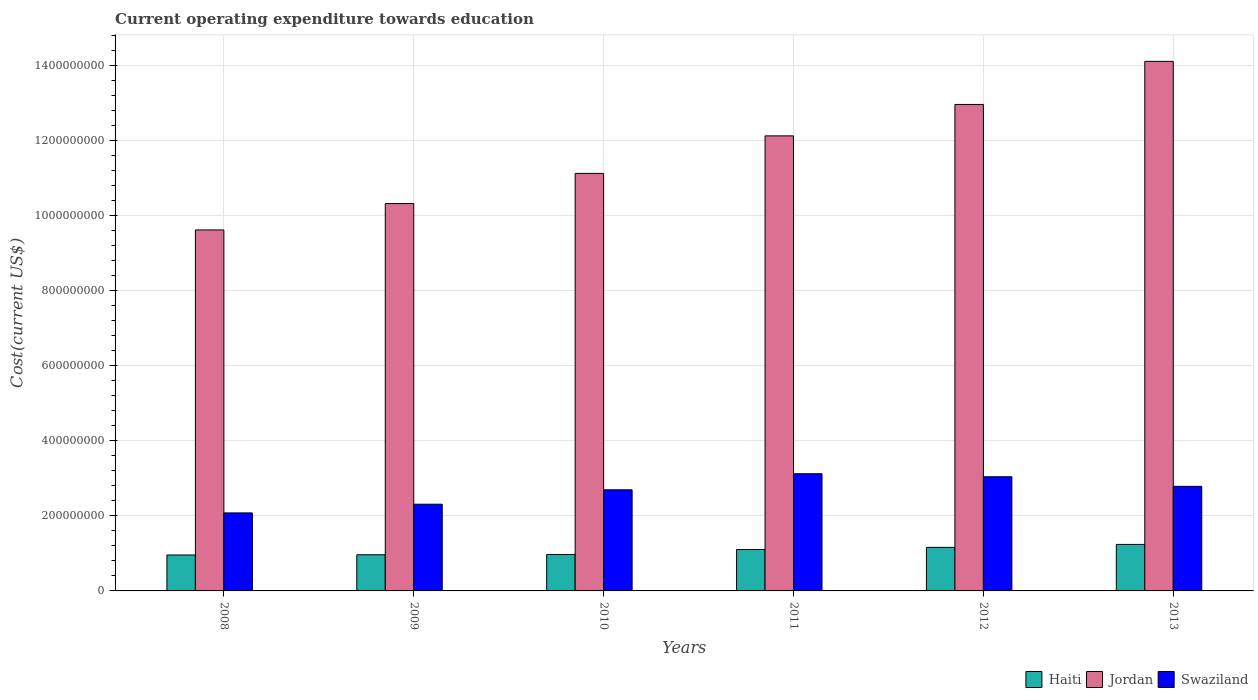How many groups of bars are there?
Keep it short and to the point. 6. Are the number of bars per tick equal to the number of legend labels?
Provide a succinct answer. Yes. Are the number of bars on each tick of the X-axis equal?
Make the answer very short. Yes. How many bars are there on the 4th tick from the right?
Provide a succinct answer. 3. What is the label of the 3rd group of bars from the left?
Your response must be concise. 2010. What is the expenditure towards education in Haiti in 2013?
Your response must be concise. 1.24e+08. Across all years, what is the maximum expenditure towards education in Haiti?
Your response must be concise. 1.24e+08. Across all years, what is the minimum expenditure towards education in Jordan?
Your answer should be very brief. 9.63e+08. In which year was the expenditure towards education in Jordan minimum?
Your answer should be very brief. 2008. What is the total expenditure towards education in Jordan in the graph?
Keep it short and to the point. 7.03e+09. What is the difference between the expenditure towards education in Swaziland in 2009 and that in 2010?
Your answer should be very brief. -3.84e+07. What is the difference between the expenditure towards education in Jordan in 2011 and the expenditure towards education in Swaziland in 2009?
Make the answer very short. 9.82e+08. What is the average expenditure towards education in Swaziland per year?
Make the answer very short. 2.67e+08. In the year 2010, what is the difference between the expenditure towards education in Haiti and expenditure towards education in Swaziland?
Make the answer very short. -1.73e+08. In how many years, is the expenditure towards education in Swaziland greater than 1280000000 US$?
Provide a short and direct response. 0. What is the ratio of the expenditure towards education in Swaziland in 2010 to that in 2011?
Your response must be concise. 0.86. Is the expenditure towards education in Swaziland in 2008 less than that in 2010?
Provide a succinct answer. Yes. What is the difference between the highest and the second highest expenditure towards education in Jordan?
Give a very brief answer. 1.15e+08. What is the difference between the highest and the lowest expenditure towards education in Jordan?
Your answer should be very brief. 4.50e+08. In how many years, is the expenditure towards education in Swaziland greater than the average expenditure towards education in Swaziland taken over all years?
Ensure brevity in your answer.  4. What does the 1st bar from the left in 2012 represents?
Keep it short and to the point. Haiti. What does the 3rd bar from the right in 2009 represents?
Offer a terse response. Haiti. Is it the case that in every year, the sum of the expenditure towards education in Haiti and expenditure towards education in Swaziland is greater than the expenditure towards education in Jordan?
Keep it short and to the point. No. How many bars are there?
Keep it short and to the point. 18. How many years are there in the graph?
Your answer should be compact. 6. What is the difference between two consecutive major ticks on the Y-axis?
Ensure brevity in your answer.  2.00e+08. Are the values on the major ticks of Y-axis written in scientific E-notation?
Your response must be concise. No. Does the graph contain any zero values?
Provide a short and direct response. No. Does the graph contain grids?
Make the answer very short. Yes. Where does the legend appear in the graph?
Provide a succinct answer. Bottom right. How many legend labels are there?
Your answer should be very brief. 3. How are the legend labels stacked?
Give a very brief answer. Horizontal. What is the title of the graph?
Keep it short and to the point. Current operating expenditure towards education. What is the label or title of the Y-axis?
Provide a succinct answer. Cost(current US$). What is the Cost(current US$) in Haiti in 2008?
Your answer should be compact. 9.58e+07. What is the Cost(current US$) in Jordan in 2008?
Your response must be concise. 9.63e+08. What is the Cost(current US$) in Swaziland in 2008?
Provide a succinct answer. 2.08e+08. What is the Cost(current US$) in Haiti in 2009?
Your answer should be very brief. 9.64e+07. What is the Cost(current US$) of Jordan in 2009?
Make the answer very short. 1.03e+09. What is the Cost(current US$) of Swaziland in 2009?
Make the answer very short. 2.31e+08. What is the Cost(current US$) of Haiti in 2010?
Your answer should be very brief. 9.71e+07. What is the Cost(current US$) of Jordan in 2010?
Give a very brief answer. 1.11e+09. What is the Cost(current US$) of Swaziland in 2010?
Your answer should be compact. 2.70e+08. What is the Cost(current US$) in Haiti in 2011?
Your answer should be compact. 1.10e+08. What is the Cost(current US$) of Jordan in 2011?
Your response must be concise. 1.21e+09. What is the Cost(current US$) of Swaziland in 2011?
Give a very brief answer. 3.12e+08. What is the Cost(current US$) of Haiti in 2012?
Your answer should be compact. 1.16e+08. What is the Cost(current US$) of Jordan in 2012?
Make the answer very short. 1.30e+09. What is the Cost(current US$) in Swaziland in 2012?
Ensure brevity in your answer.  3.04e+08. What is the Cost(current US$) of Haiti in 2013?
Give a very brief answer. 1.24e+08. What is the Cost(current US$) in Jordan in 2013?
Make the answer very short. 1.41e+09. What is the Cost(current US$) of Swaziland in 2013?
Your answer should be compact. 2.79e+08. Across all years, what is the maximum Cost(current US$) in Haiti?
Provide a short and direct response. 1.24e+08. Across all years, what is the maximum Cost(current US$) of Jordan?
Provide a succinct answer. 1.41e+09. Across all years, what is the maximum Cost(current US$) in Swaziland?
Keep it short and to the point. 3.12e+08. Across all years, what is the minimum Cost(current US$) in Haiti?
Offer a terse response. 9.58e+07. Across all years, what is the minimum Cost(current US$) of Jordan?
Offer a terse response. 9.63e+08. Across all years, what is the minimum Cost(current US$) in Swaziland?
Provide a short and direct response. 2.08e+08. What is the total Cost(current US$) in Haiti in the graph?
Your answer should be very brief. 6.40e+08. What is the total Cost(current US$) in Jordan in the graph?
Offer a terse response. 7.03e+09. What is the total Cost(current US$) in Swaziland in the graph?
Offer a very short reply. 1.60e+09. What is the difference between the Cost(current US$) of Haiti in 2008 and that in 2009?
Provide a short and direct response. -6.34e+05. What is the difference between the Cost(current US$) in Jordan in 2008 and that in 2009?
Keep it short and to the point. -7.04e+07. What is the difference between the Cost(current US$) in Swaziland in 2008 and that in 2009?
Keep it short and to the point. -2.32e+07. What is the difference between the Cost(current US$) of Haiti in 2008 and that in 2010?
Give a very brief answer. -1.33e+06. What is the difference between the Cost(current US$) of Jordan in 2008 and that in 2010?
Make the answer very short. -1.51e+08. What is the difference between the Cost(current US$) of Swaziland in 2008 and that in 2010?
Your answer should be very brief. -6.16e+07. What is the difference between the Cost(current US$) in Haiti in 2008 and that in 2011?
Give a very brief answer. -1.46e+07. What is the difference between the Cost(current US$) in Jordan in 2008 and that in 2011?
Your response must be concise. -2.51e+08. What is the difference between the Cost(current US$) in Swaziland in 2008 and that in 2011?
Your response must be concise. -1.04e+08. What is the difference between the Cost(current US$) in Haiti in 2008 and that in 2012?
Keep it short and to the point. -2.03e+07. What is the difference between the Cost(current US$) in Jordan in 2008 and that in 2012?
Give a very brief answer. -3.35e+08. What is the difference between the Cost(current US$) of Swaziland in 2008 and that in 2012?
Make the answer very short. -9.64e+07. What is the difference between the Cost(current US$) of Haiti in 2008 and that in 2013?
Provide a short and direct response. -2.82e+07. What is the difference between the Cost(current US$) in Jordan in 2008 and that in 2013?
Give a very brief answer. -4.50e+08. What is the difference between the Cost(current US$) of Swaziland in 2008 and that in 2013?
Provide a short and direct response. -7.09e+07. What is the difference between the Cost(current US$) of Haiti in 2009 and that in 2010?
Make the answer very short. -6.92e+05. What is the difference between the Cost(current US$) of Jordan in 2009 and that in 2010?
Provide a succinct answer. -8.04e+07. What is the difference between the Cost(current US$) in Swaziland in 2009 and that in 2010?
Offer a terse response. -3.84e+07. What is the difference between the Cost(current US$) of Haiti in 2009 and that in 2011?
Your answer should be compact. -1.40e+07. What is the difference between the Cost(current US$) of Jordan in 2009 and that in 2011?
Give a very brief answer. -1.80e+08. What is the difference between the Cost(current US$) of Swaziland in 2009 and that in 2011?
Give a very brief answer. -8.13e+07. What is the difference between the Cost(current US$) in Haiti in 2009 and that in 2012?
Offer a terse response. -1.97e+07. What is the difference between the Cost(current US$) of Jordan in 2009 and that in 2012?
Make the answer very short. -2.64e+08. What is the difference between the Cost(current US$) in Swaziland in 2009 and that in 2012?
Provide a succinct answer. -7.32e+07. What is the difference between the Cost(current US$) in Haiti in 2009 and that in 2013?
Make the answer very short. -2.76e+07. What is the difference between the Cost(current US$) of Jordan in 2009 and that in 2013?
Provide a succinct answer. -3.79e+08. What is the difference between the Cost(current US$) in Swaziland in 2009 and that in 2013?
Give a very brief answer. -4.77e+07. What is the difference between the Cost(current US$) in Haiti in 2010 and that in 2011?
Ensure brevity in your answer.  -1.33e+07. What is the difference between the Cost(current US$) in Jordan in 2010 and that in 2011?
Offer a very short reply. -1.00e+08. What is the difference between the Cost(current US$) of Swaziland in 2010 and that in 2011?
Your answer should be very brief. -4.29e+07. What is the difference between the Cost(current US$) of Haiti in 2010 and that in 2012?
Offer a terse response. -1.90e+07. What is the difference between the Cost(current US$) in Jordan in 2010 and that in 2012?
Ensure brevity in your answer.  -1.84e+08. What is the difference between the Cost(current US$) of Swaziland in 2010 and that in 2012?
Keep it short and to the point. -3.48e+07. What is the difference between the Cost(current US$) of Haiti in 2010 and that in 2013?
Give a very brief answer. -2.69e+07. What is the difference between the Cost(current US$) of Jordan in 2010 and that in 2013?
Give a very brief answer. -2.99e+08. What is the difference between the Cost(current US$) in Swaziland in 2010 and that in 2013?
Make the answer very short. -9.25e+06. What is the difference between the Cost(current US$) in Haiti in 2011 and that in 2012?
Provide a succinct answer. -5.70e+06. What is the difference between the Cost(current US$) in Jordan in 2011 and that in 2012?
Your answer should be compact. -8.38e+07. What is the difference between the Cost(current US$) in Swaziland in 2011 and that in 2012?
Provide a short and direct response. 8.08e+06. What is the difference between the Cost(current US$) in Haiti in 2011 and that in 2013?
Give a very brief answer. -1.36e+07. What is the difference between the Cost(current US$) of Jordan in 2011 and that in 2013?
Your answer should be compact. -1.99e+08. What is the difference between the Cost(current US$) of Swaziland in 2011 and that in 2013?
Your response must be concise. 3.36e+07. What is the difference between the Cost(current US$) of Haiti in 2012 and that in 2013?
Your response must be concise. -7.89e+06. What is the difference between the Cost(current US$) of Jordan in 2012 and that in 2013?
Ensure brevity in your answer.  -1.15e+08. What is the difference between the Cost(current US$) of Swaziland in 2012 and that in 2013?
Provide a short and direct response. 2.55e+07. What is the difference between the Cost(current US$) in Haiti in 2008 and the Cost(current US$) in Jordan in 2009?
Provide a short and direct response. -9.37e+08. What is the difference between the Cost(current US$) in Haiti in 2008 and the Cost(current US$) in Swaziland in 2009?
Make the answer very short. -1.35e+08. What is the difference between the Cost(current US$) in Jordan in 2008 and the Cost(current US$) in Swaziland in 2009?
Offer a terse response. 7.31e+08. What is the difference between the Cost(current US$) in Haiti in 2008 and the Cost(current US$) in Jordan in 2010?
Ensure brevity in your answer.  -1.02e+09. What is the difference between the Cost(current US$) in Haiti in 2008 and the Cost(current US$) in Swaziland in 2010?
Your answer should be compact. -1.74e+08. What is the difference between the Cost(current US$) in Jordan in 2008 and the Cost(current US$) in Swaziland in 2010?
Keep it short and to the point. 6.93e+08. What is the difference between the Cost(current US$) in Haiti in 2008 and the Cost(current US$) in Jordan in 2011?
Offer a terse response. -1.12e+09. What is the difference between the Cost(current US$) of Haiti in 2008 and the Cost(current US$) of Swaziland in 2011?
Provide a succinct answer. -2.17e+08. What is the difference between the Cost(current US$) in Jordan in 2008 and the Cost(current US$) in Swaziland in 2011?
Keep it short and to the point. 6.50e+08. What is the difference between the Cost(current US$) of Haiti in 2008 and the Cost(current US$) of Jordan in 2012?
Ensure brevity in your answer.  -1.20e+09. What is the difference between the Cost(current US$) in Haiti in 2008 and the Cost(current US$) in Swaziland in 2012?
Provide a short and direct response. -2.09e+08. What is the difference between the Cost(current US$) in Jordan in 2008 and the Cost(current US$) in Swaziland in 2012?
Provide a succinct answer. 6.58e+08. What is the difference between the Cost(current US$) in Haiti in 2008 and the Cost(current US$) in Jordan in 2013?
Make the answer very short. -1.32e+09. What is the difference between the Cost(current US$) in Haiti in 2008 and the Cost(current US$) in Swaziland in 2013?
Ensure brevity in your answer.  -1.83e+08. What is the difference between the Cost(current US$) in Jordan in 2008 and the Cost(current US$) in Swaziland in 2013?
Your response must be concise. 6.84e+08. What is the difference between the Cost(current US$) in Haiti in 2009 and the Cost(current US$) in Jordan in 2010?
Keep it short and to the point. -1.02e+09. What is the difference between the Cost(current US$) in Haiti in 2009 and the Cost(current US$) in Swaziland in 2010?
Give a very brief answer. -1.73e+08. What is the difference between the Cost(current US$) in Jordan in 2009 and the Cost(current US$) in Swaziland in 2010?
Ensure brevity in your answer.  7.63e+08. What is the difference between the Cost(current US$) in Haiti in 2009 and the Cost(current US$) in Jordan in 2011?
Your answer should be very brief. -1.12e+09. What is the difference between the Cost(current US$) of Haiti in 2009 and the Cost(current US$) of Swaziland in 2011?
Your answer should be very brief. -2.16e+08. What is the difference between the Cost(current US$) of Jordan in 2009 and the Cost(current US$) of Swaziland in 2011?
Your response must be concise. 7.20e+08. What is the difference between the Cost(current US$) in Haiti in 2009 and the Cost(current US$) in Jordan in 2012?
Offer a very short reply. -1.20e+09. What is the difference between the Cost(current US$) in Haiti in 2009 and the Cost(current US$) in Swaziland in 2012?
Ensure brevity in your answer.  -2.08e+08. What is the difference between the Cost(current US$) in Jordan in 2009 and the Cost(current US$) in Swaziland in 2012?
Ensure brevity in your answer.  7.28e+08. What is the difference between the Cost(current US$) of Haiti in 2009 and the Cost(current US$) of Jordan in 2013?
Keep it short and to the point. -1.32e+09. What is the difference between the Cost(current US$) of Haiti in 2009 and the Cost(current US$) of Swaziland in 2013?
Provide a succinct answer. -1.82e+08. What is the difference between the Cost(current US$) of Jordan in 2009 and the Cost(current US$) of Swaziland in 2013?
Make the answer very short. 7.54e+08. What is the difference between the Cost(current US$) in Haiti in 2010 and the Cost(current US$) in Jordan in 2011?
Your answer should be compact. -1.12e+09. What is the difference between the Cost(current US$) of Haiti in 2010 and the Cost(current US$) of Swaziland in 2011?
Your answer should be very brief. -2.15e+08. What is the difference between the Cost(current US$) in Jordan in 2010 and the Cost(current US$) in Swaziland in 2011?
Provide a short and direct response. 8.01e+08. What is the difference between the Cost(current US$) in Haiti in 2010 and the Cost(current US$) in Jordan in 2012?
Your answer should be compact. -1.20e+09. What is the difference between the Cost(current US$) in Haiti in 2010 and the Cost(current US$) in Swaziland in 2012?
Provide a succinct answer. -2.07e+08. What is the difference between the Cost(current US$) of Jordan in 2010 and the Cost(current US$) of Swaziland in 2012?
Make the answer very short. 8.09e+08. What is the difference between the Cost(current US$) of Haiti in 2010 and the Cost(current US$) of Jordan in 2013?
Keep it short and to the point. -1.31e+09. What is the difference between the Cost(current US$) of Haiti in 2010 and the Cost(current US$) of Swaziland in 2013?
Make the answer very short. -1.82e+08. What is the difference between the Cost(current US$) in Jordan in 2010 and the Cost(current US$) in Swaziland in 2013?
Keep it short and to the point. 8.34e+08. What is the difference between the Cost(current US$) of Haiti in 2011 and the Cost(current US$) of Jordan in 2012?
Ensure brevity in your answer.  -1.19e+09. What is the difference between the Cost(current US$) of Haiti in 2011 and the Cost(current US$) of Swaziland in 2012?
Your response must be concise. -1.94e+08. What is the difference between the Cost(current US$) of Jordan in 2011 and the Cost(current US$) of Swaziland in 2012?
Provide a short and direct response. 9.09e+08. What is the difference between the Cost(current US$) in Haiti in 2011 and the Cost(current US$) in Jordan in 2013?
Offer a very short reply. -1.30e+09. What is the difference between the Cost(current US$) of Haiti in 2011 and the Cost(current US$) of Swaziland in 2013?
Provide a succinct answer. -1.68e+08. What is the difference between the Cost(current US$) of Jordan in 2011 and the Cost(current US$) of Swaziland in 2013?
Your response must be concise. 9.34e+08. What is the difference between the Cost(current US$) of Haiti in 2012 and the Cost(current US$) of Jordan in 2013?
Your response must be concise. -1.30e+09. What is the difference between the Cost(current US$) in Haiti in 2012 and the Cost(current US$) in Swaziland in 2013?
Offer a terse response. -1.63e+08. What is the difference between the Cost(current US$) in Jordan in 2012 and the Cost(current US$) in Swaziland in 2013?
Give a very brief answer. 1.02e+09. What is the average Cost(current US$) in Haiti per year?
Your answer should be very brief. 1.07e+08. What is the average Cost(current US$) in Jordan per year?
Keep it short and to the point. 1.17e+09. What is the average Cost(current US$) in Swaziland per year?
Provide a short and direct response. 2.67e+08. In the year 2008, what is the difference between the Cost(current US$) of Haiti and Cost(current US$) of Jordan?
Offer a terse response. -8.67e+08. In the year 2008, what is the difference between the Cost(current US$) in Haiti and Cost(current US$) in Swaziland?
Your response must be concise. -1.12e+08. In the year 2008, what is the difference between the Cost(current US$) of Jordan and Cost(current US$) of Swaziland?
Make the answer very short. 7.55e+08. In the year 2009, what is the difference between the Cost(current US$) in Haiti and Cost(current US$) in Jordan?
Your answer should be very brief. -9.36e+08. In the year 2009, what is the difference between the Cost(current US$) in Haiti and Cost(current US$) in Swaziland?
Your answer should be very brief. -1.35e+08. In the year 2009, what is the difference between the Cost(current US$) in Jordan and Cost(current US$) in Swaziland?
Your answer should be very brief. 8.02e+08. In the year 2010, what is the difference between the Cost(current US$) in Haiti and Cost(current US$) in Jordan?
Offer a terse response. -1.02e+09. In the year 2010, what is the difference between the Cost(current US$) in Haiti and Cost(current US$) in Swaziland?
Provide a succinct answer. -1.73e+08. In the year 2010, what is the difference between the Cost(current US$) of Jordan and Cost(current US$) of Swaziland?
Offer a very short reply. 8.44e+08. In the year 2011, what is the difference between the Cost(current US$) in Haiti and Cost(current US$) in Jordan?
Your response must be concise. -1.10e+09. In the year 2011, what is the difference between the Cost(current US$) in Haiti and Cost(current US$) in Swaziland?
Offer a terse response. -2.02e+08. In the year 2011, what is the difference between the Cost(current US$) of Jordan and Cost(current US$) of Swaziland?
Offer a very short reply. 9.01e+08. In the year 2012, what is the difference between the Cost(current US$) in Haiti and Cost(current US$) in Jordan?
Provide a short and direct response. -1.18e+09. In the year 2012, what is the difference between the Cost(current US$) in Haiti and Cost(current US$) in Swaziland?
Offer a terse response. -1.88e+08. In the year 2012, what is the difference between the Cost(current US$) of Jordan and Cost(current US$) of Swaziland?
Offer a very short reply. 9.93e+08. In the year 2013, what is the difference between the Cost(current US$) of Haiti and Cost(current US$) of Jordan?
Your answer should be compact. -1.29e+09. In the year 2013, what is the difference between the Cost(current US$) in Haiti and Cost(current US$) in Swaziland?
Provide a short and direct response. -1.55e+08. In the year 2013, what is the difference between the Cost(current US$) in Jordan and Cost(current US$) in Swaziland?
Your answer should be very brief. 1.13e+09. What is the ratio of the Cost(current US$) of Haiti in 2008 to that in 2009?
Make the answer very short. 0.99. What is the ratio of the Cost(current US$) in Jordan in 2008 to that in 2009?
Offer a terse response. 0.93. What is the ratio of the Cost(current US$) of Swaziland in 2008 to that in 2009?
Offer a terse response. 0.9. What is the ratio of the Cost(current US$) in Haiti in 2008 to that in 2010?
Keep it short and to the point. 0.99. What is the ratio of the Cost(current US$) in Jordan in 2008 to that in 2010?
Your answer should be very brief. 0.86. What is the ratio of the Cost(current US$) of Swaziland in 2008 to that in 2010?
Provide a succinct answer. 0.77. What is the ratio of the Cost(current US$) in Haiti in 2008 to that in 2011?
Provide a succinct answer. 0.87. What is the ratio of the Cost(current US$) in Jordan in 2008 to that in 2011?
Your answer should be very brief. 0.79. What is the ratio of the Cost(current US$) of Swaziland in 2008 to that in 2011?
Provide a succinct answer. 0.67. What is the ratio of the Cost(current US$) in Haiti in 2008 to that in 2012?
Offer a very short reply. 0.82. What is the ratio of the Cost(current US$) in Jordan in 2008 to that in 2012?
Ensure brevity in your answer.  0.74. What is the ratio of the Cost(current US$) in Swaziland in 2008 to that in 2012?
Offer a very short reply. 0.68. What is the ratio of the Cost(current US$) in Haiti in 2008 to that in 2013?
Give a very brief answer. 0.77. What is the ratio of the Cost(current US$) in Jordan in 2008 to that in 2013?
Give a very brief answer. 0.68. What is the ratio of the Cost(current US$) in Swaziland in 2008 to that in 2013?
Keep it short and to the point. 0.75. What is the ratio of the Cost(current US$) of Haiti in 2009 to that in 2010?
Your answer should be compact. 0.99. What is the ratio of the Cost(current US$) of Jordan in 2009 to that in 2010?
Offer a terse response. 0.93. What is the ratio of the Cost(current US$) in Swaziland in 2009 to that in 2010?
Offer a very short reply. 0.86. What is the ratio of the Cost(current US$) of Haiti in 2009 to that in 2011?
Offer a very short reply. 0.87. What is the ratio of the Cost(current US$) of Jordan in 2009 to that in 2011?
Make the answer very short. 0.85. What is the ratio of the Cost(current US$) in Swaziland in 2009 to that in 2011?
Your answer should be compact. 0.74. What is the ratio of the Cost(current US$) of Haiti in 2009 to that in 2012?
Keep it short and to the point. 0.83. What is the ratio of the Cost(current US$) of Jordan in 2009 to that in 2012?
Ensure brevity in your answer.  0.8. What is the ratio of the Cost(current US$) in Swaziland in 2009 to that in 2012?
Provide a short and direct response. 0.76. What is the ratio of the Cost(current US$) of Haiti in 2009 to that in 2013?
Your answer should be very brief. 0.78. What is the ratio of the Cost(current US$) in Jordan in 2009 to that in 2013?
Provide a succinct answer. 0.73. What is the ratio of the Cost(current US$) in Swaziland in 2009 to that in 2013?
Give a very brief answer. 0.83. What is the ratio of the Cost(current US$) of Haiti in 2010 to that in 2011?
Offer a terse response. 0.88. What is the ratio of the Cost(current US$) of Jordan in 2010 to that in 2011?
Offer a very short reply. 0.92. What is the ratio of the Cost(current US$) of Swaziland in 2010 to that in 2011?
Your answer should be compact. 0.86. What is the ratio of the Cost(current US$) of Haiti in 2010 to that in 2012?
Offer a very short reply. 0.84. What is the ratio of the Cost(current US$) of Jordan in 2010 to that in 2012?
Keep it short and to the point. 0.86. What is the ratio of the Cost(current US$) of Swaziland in 2010 to that in 2012?
Ensure brevity in your answer.  0.89. What is the ratio of the Cost(current US$) in Haiti in 2010 to that in 2013?
Keep it short and to the point. 0.78. What is the ratio of the Cost(current US$) of Jordan in 2010 to that in 2013?
Provide a succinct answer. 0.79. What is the ratio of the Cost(current US$) of Swaziland in 2010 to that in 2013?
Keep it short and to the point. 0.97. What is the ratio of the Cost(current US$) in Haiti in 2011 to that in 2012?
Ensure brevity in your answer.  0.95. What is the ratio of the Cost(current US$) in Jordan in 2011 to that in 2012?
Make the answer very short. 0.94. What is the ratio of the Cost(current US$) of Swaziland in 2011 to that in 2012?
Make the answer very short. 1.03. What is the ratio of the Cost(current US$) of Haiti in 2011 to that in 2013?
Your answer should be very brief. 0.89. What is the ratio of the Cost(current US$) of Jordan in 2011 to that in 2013?
Provide a succinct answer. 0.86. What is the ratio of the Cost(current US$) in Swaziland in 2011 to that in 2013?
Offer a very short reply. 1.12. What is the ratio of the Cost(current US$) in Haiti in 2012 to that in 2013?
Make the answer very short. 0.94. What is the ratio of the Cost(current US$) of Jordan in 2012 to that in 2013?
Your response must be concise. 0.92. What is the ratio of the Cost(current US$) of Swaziland in 2012 to that in 2013?
Offer a very short reply. 1.09. What is the difference between the highest and the second highest Cost(current US$) in Haiti?
Keep it short and to the point. 7.89e+06. What is the difference between the highest and the second highest Cost(current US$) in Jordan?
Keep it short and to the point. 1.15e+08. What is the difference between the highest and the second highest Cost(current US$) of Swaziland?
Your answer should be very brief. 8.08e+06. What is the difference between the highest and the lowest Cost(current US$) of Haiti?
Your answer should be very brief. 2.82e+07. What is the difference between the highest and the lowest Cost(current US$) in Jordan?
Your answer should be very brief. 4.50e+08. What is the difference between the highest and the lowest Cost(current US$) of Swaziland?
Provide a succinct answer. 1.04e+08. 